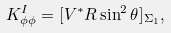<formula> <loc_0><loc_0><loc_500><loc_500>K ^ { I } _ { \phi \phi } = [ V ^ { * } R \sin ^ { 2 } \theta ] _ { \Sigma _ { 1 } } ,</formula> 